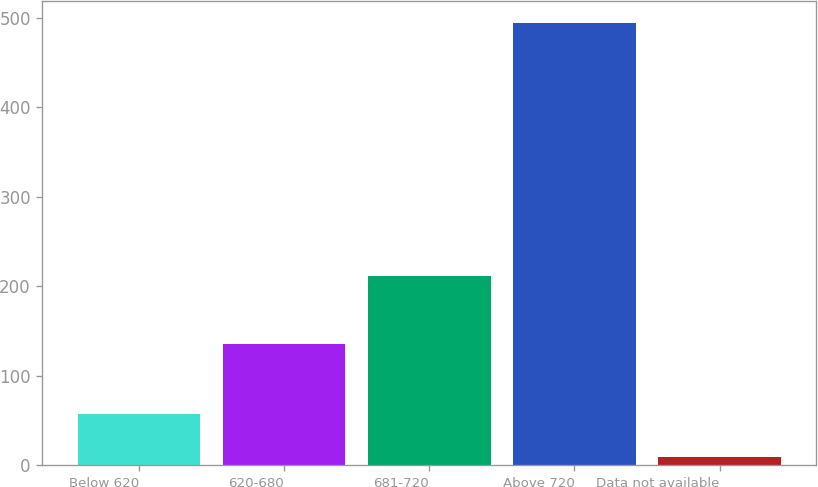<chart> <loc_0><loc_0><loc_500><loc_500><bar_chart><fcel>Below 620<fcel>620-680<fcel>681-720<fcel>Above 720<fcel>Data not available<nl><fcel>57.5<fcel>135<fcel>211<fcel>494<fcel>9<nl></chart> 